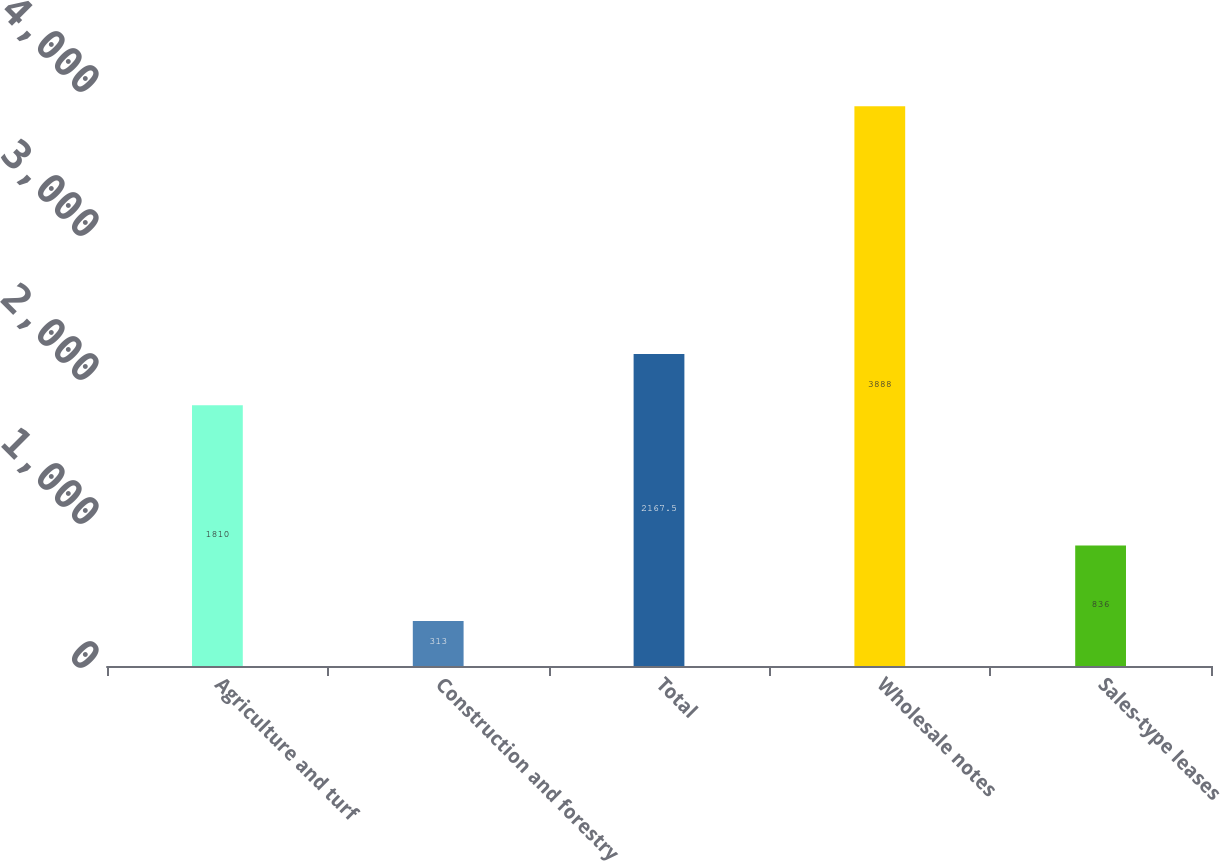Convert chart. <chart><loc_0><loc_0><loc_500><loc_500><bar_chart><fcel>Agriculture and turf<fcel>Construction and forestry<fcel>Total<fcel>Wholesale notes<fcel>Sales-type leases<nl><fcel>1810<fcel>313<fcel>2167.5<fcel>3888<fcel>836<nl></chart> 